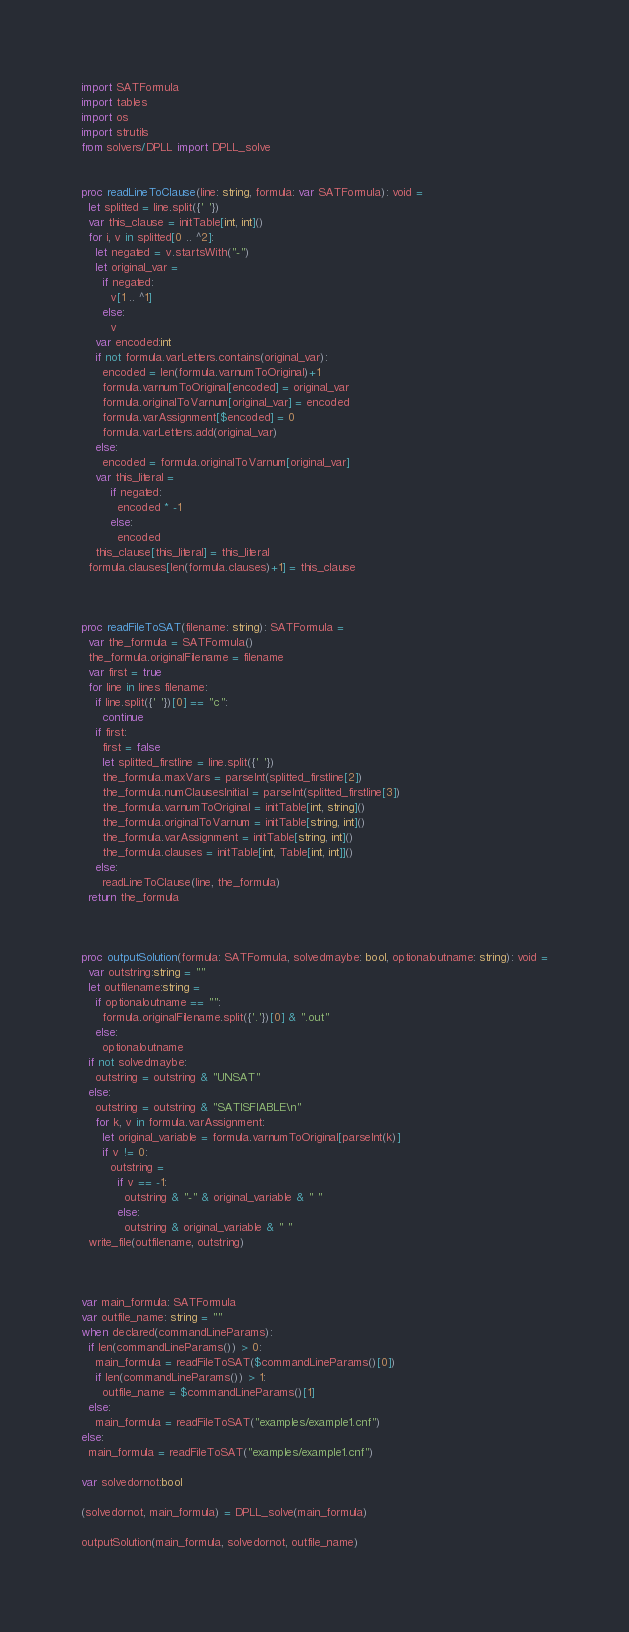Convert code to text. <code><loc_0><loc_0><loc_500><loc_500><_Nim_>import SATFormula
import tables
import os
import strutils
from solvers/DPLL import DPLL_solve


proc readLineToClause(line: string, formula: var SATFormula): void =
  let splitted = line.split({' '})
  var this_clause = initTable[int, int]()
  for i, v in splitted[0 .. ^2]:
    let negated = v.startsWith("-")
    let original_var =
      if negated:
        v[1 .. ^1]
      else:
        v
    var encoded:int
    if not formula.varLetters.contains(original_var):
      encoded = len(formula.varnumToOriginal)+1
      formula.varnumToOriginal[encoded] = original_var
      formula.originalToVarnum[original_var] = encoded
      formula.varAssignment[$encoded] = 0
      formula.varLetters.add(original_var)
    else:
      encoded = formula.originalToVarnum[original_var]
    var this_literal = 
        if negated:
          encoded * -1
        else:
          encoded
    this_clause[this_literal] = this_literal
  formula.clauses[len(formula.clauses)+1] = this_clause



proc readFileToSAT(filename: string): SATFormula =
  var the_formula = SATFormula()
  the_formula.originalFilename = filename
  var first = true
  for line in lines filename:
    if line.split({' '})[0] == "c":
      continue
    if first:
      first = false
      let splitted_firstline = line.split({' '})
      the_formula.maxVars = parseInt(splitted_firstline[2])
      the_formula.numClausesInitial = parseInt(splitted_firstline[3])
      the_formula.varnumToOriginal = initTable[int, string]()
      the_formula.originalToVarnum = initTable[string, int]()
      the_formula.varAssignment = initTable[string, int]()
      the_formula.clauses = initTable[int, Table[int, int]]()
    else:
      readLineToClause(line, the_formula)
  return the_formula



proc outputSolution(formula: SATFormula, solvedmaybe: bool, optionaloutname: string): void =
  var outstring:string = ""
  let outfilename:string = 
    if optionaloutname == "":
      formula.originalFilename.split({'.'})[0] & ".out"
    else:
      optionaloutname
  if not solvedmaybe:
    outstring = outstring & "UNSAT"
  else:
    outstring = outstring & "SATISFIABLE\n"
    for k, v in formula.varAssignment:
      let original_variable = formula.varnumToOriginal[parseInt(k)]
      if v != 0:
        outstring = 
          if v == -1:
            outstring & "-" & original_variable & " "
          else:
            outstring & original_variable & " "
  write_file(outfilename, outstring)



var main_formula: SATFormula
var outfile_name: string = ""
when declared(commandLineParams):
  if len(commandLineParams()) > 0:
    main_formula = readFileToSAT($commandLineParams()[0])
    if len(commandLineParams()) > 1:
      outfile_name = $commandLineParams()[1]
  else:
    main_formula = readFileToSAT("examples/example1.cnf")
else:
  main_formula = readFileToSAT("examples/example1.cnf")

var solvedornot:bool

(solvedornot, main_formula) = DPLL_solve(main_formula)

outputSolution(main_formula, solvedornot, outfile_name)</code> 